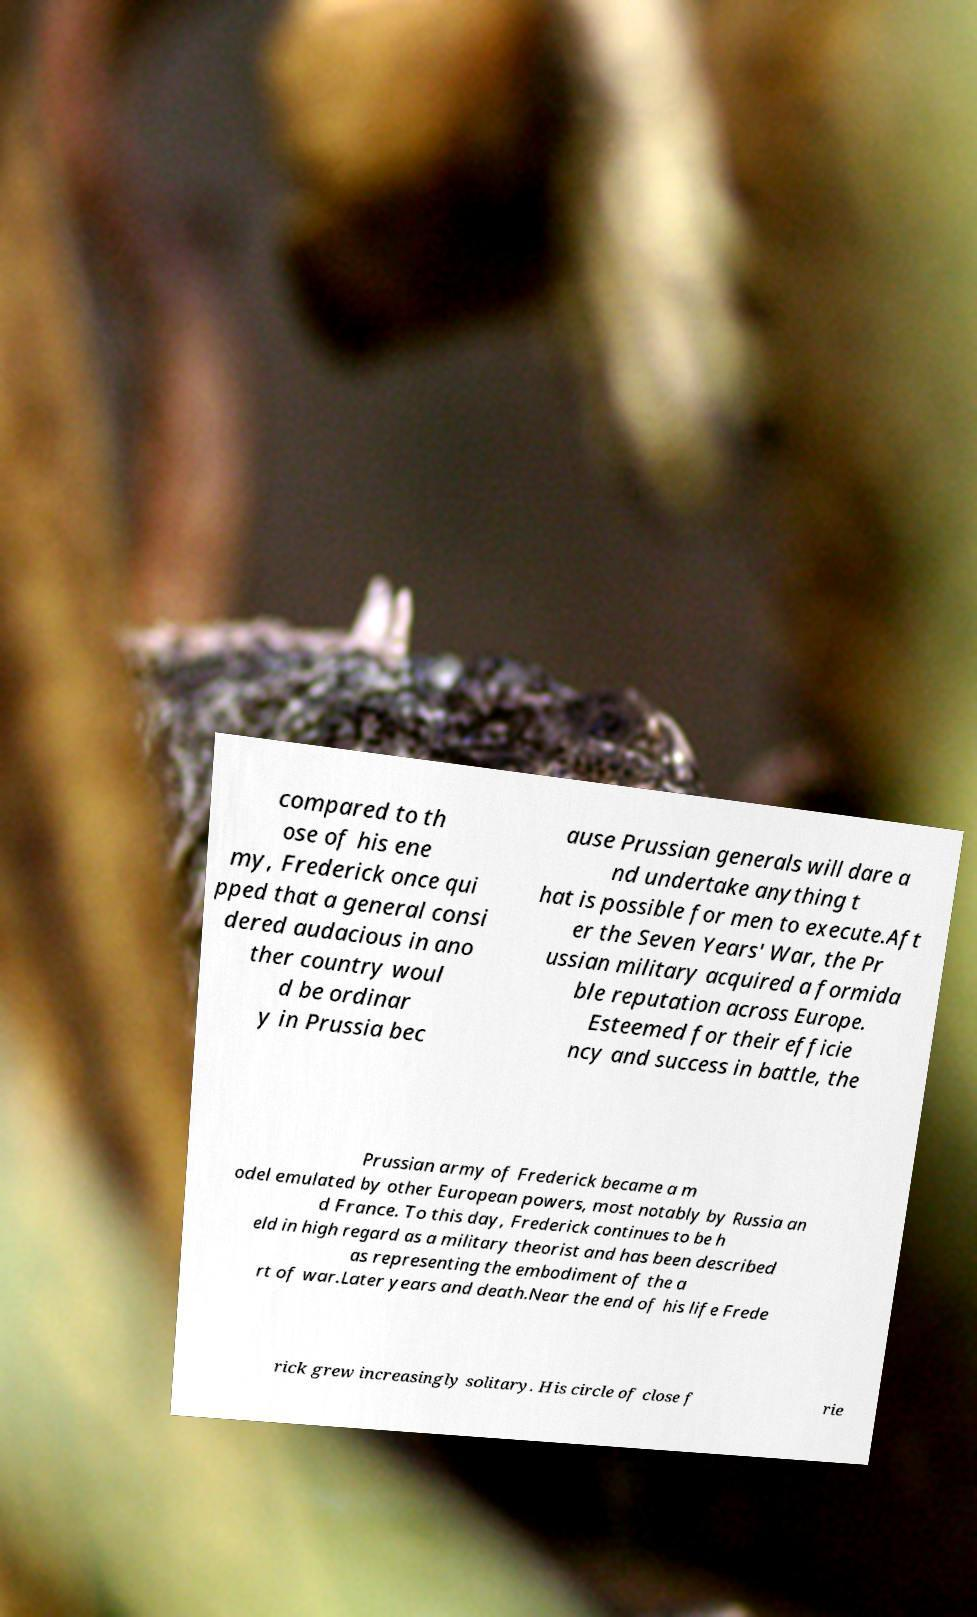Please read and relay the text visible in this image. What does it say? compared to th ose of his ene my, Frederick once qui pped that a general consi dered audacious in ano ther country woul d be ordinar y in Prussia bec ause Prussian generals will dare a nd undertake anything t hat is possible for men to execute.Aft er the Seven Years' War, the Pr ussian military acquired a formida ble reputation across Europe. Esteemed for their efficie ncy and success in battle, the Prussian army of Frederick became a m odel emulated by other European powers, most notably by Russia an d France. To this day, Frederick continues to be h eld in high regard as a military theorist and has been described as representing the embodiment of the a rt of war.Later years and death.Near the end of his life Frede rick grew increasingly solitary. His circle of close f rie 